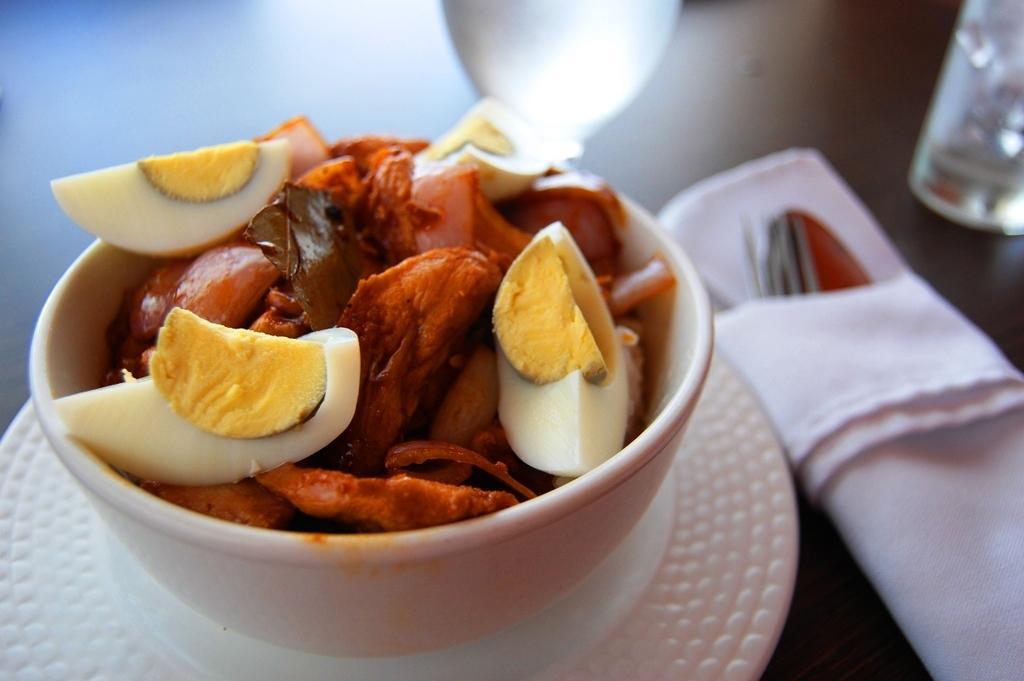Please provide a concise description of this image. In this picture we can see some eatable item placed on a bowl, spoon, tissue are placed on the table. 